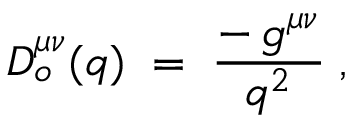<formula> <loc_0><loc_0><loc_500><loc_500>D _ { o } ^ { \mu \nu } ( q ) \, = \, { \frac { - \, g ^ { \mu \nu } } { q ^ { 2 } } } \, ,</formula> 